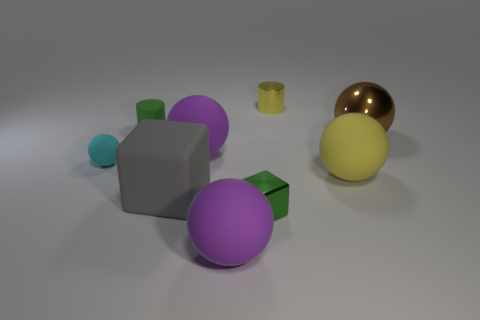Subtract all big brown metallic spheres. How many spheres are left? 4 Subtract all purple spheres. How many spheres are left? 3 Subtract all balls. How many objects are left? 4 Add 8 green cylinders. How many green cylinders exist? 9 Subtract 1 yellow spheres. How many objects are left? 8 Subtract 1 balls. How many balls are left? 4 Subtract all red balls. Subtract all brown cubes. How many balls are left? 5 Subtract all purple balls. How many yellow cylinders are left? 1 Subtract all tiny metal things. Subtract all big rubber blocks. How many objects are left? 6 Add 4 cyan things. How many cyan things are left? 5 